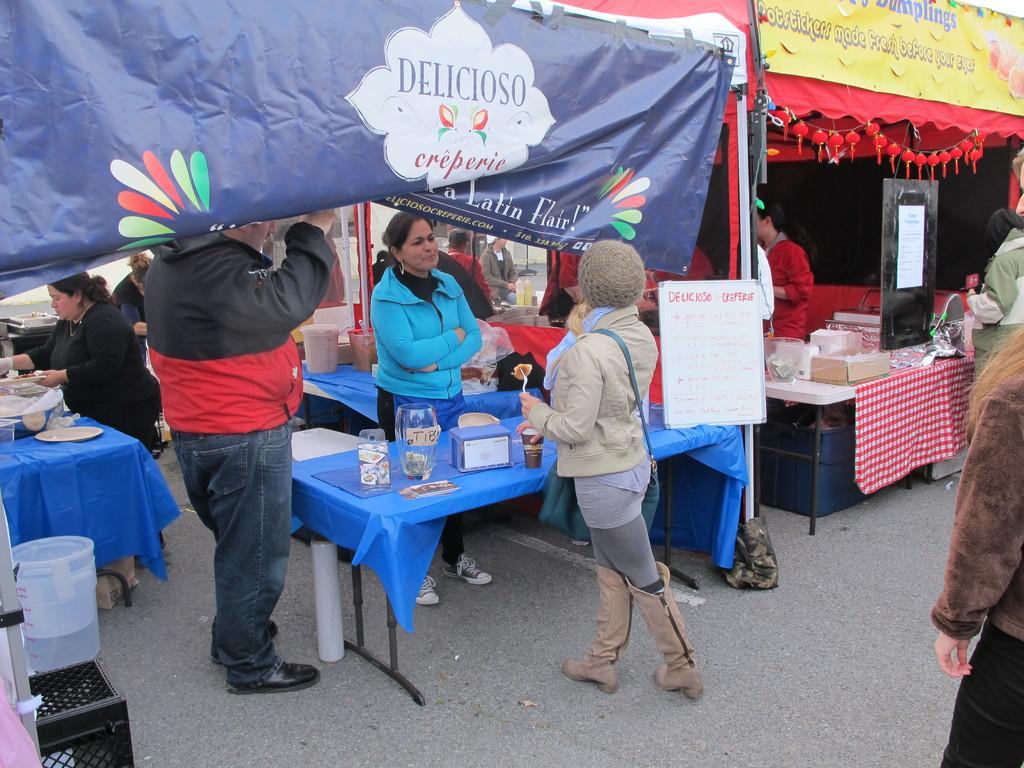Could you give a brief overview of what you see in this image? In this image there is a stall. In the stall there are tables with stuff on it, in front of the tables there are persons standing, there is a lady standing outside the stall. On the bottom left side there are few objects placed on the surface, beside this stall there is another stall. In the stall there is a table with some stuff on it, in front of the table there is a person standing. On the right side of the image there are a few people standing. 